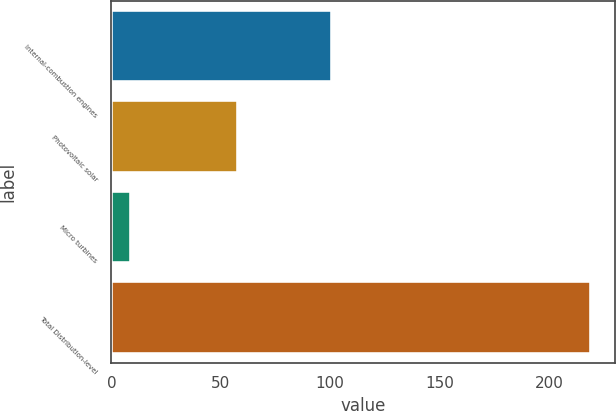Convert chart. <chart><loc_0><loc_0><loc_500><loc_500><bar_chart><fcel>Internal-combustion engines<fcel>Photovoltaic solar<fcel>Micro turbines<fcel>Total Distribution-level<nl><fcel>101<fcel>58<fcel>9<fcel>219<nl></chart> 